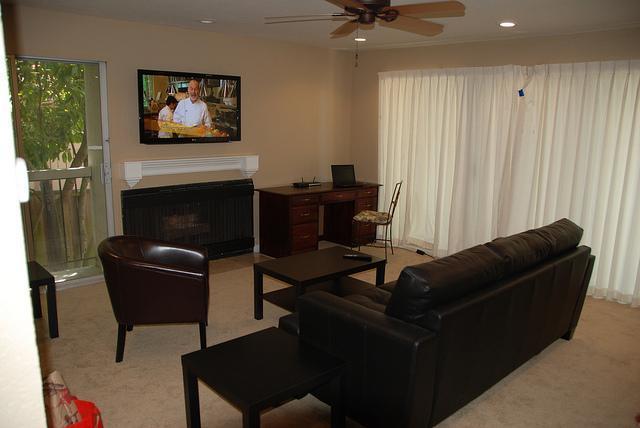How many throw pillows are on the sofa?
Give a very brief answer. 0. How many couches are there?
Give a very brief answer. 1. 